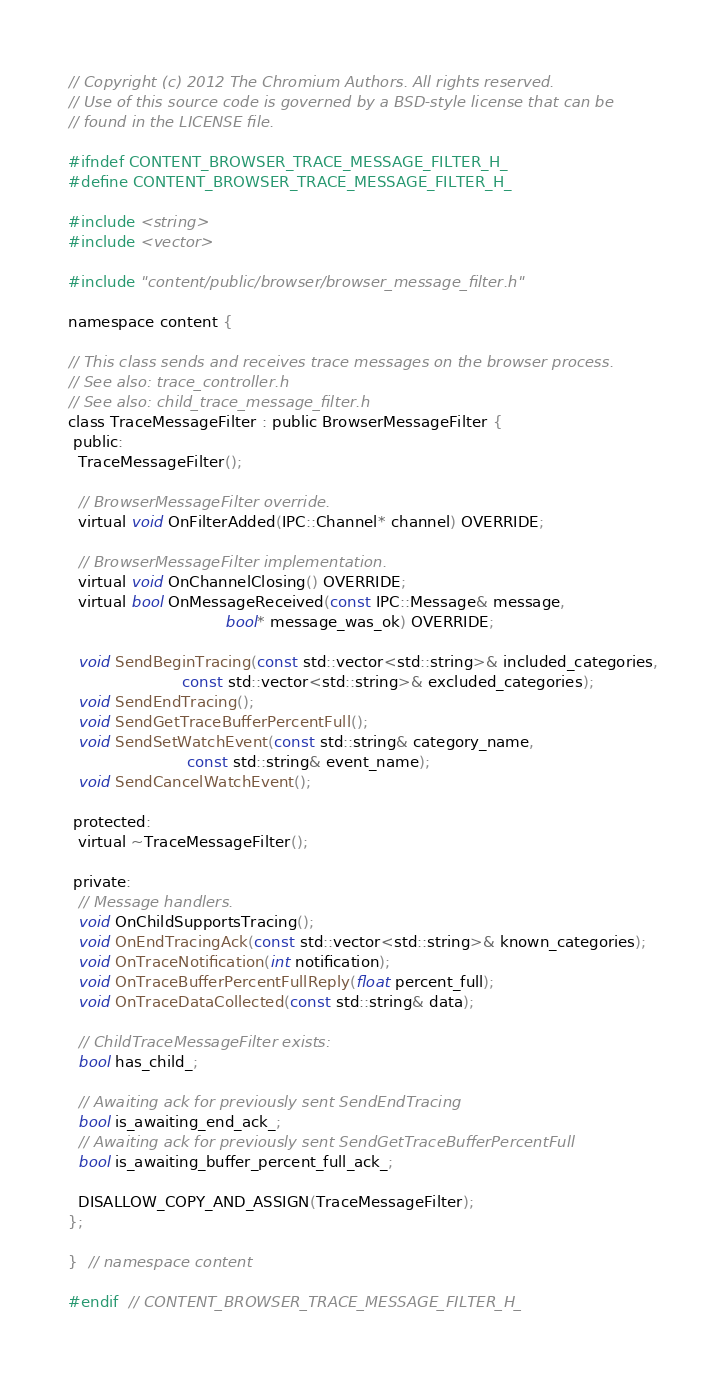Convert code to text. <code><loc_0><loc_0><loc_500><loc_500><_C_>// Copyright (c) 2012 The Chromium Authors. All rights reserved.
// Use of this source code is governed by a BSD-style license that can be
// found in the LICENSE file.

#ifndef CONTENT_BROWSER_TRACE_MESSAGE_FILTER_H_
#define CONTENT_BROWSER_TRACE_MESSAGE_FILTER_H_

#include <string>
#include <vector>

#include "content/public/browser/browser_message_filter.h"

namespace content {

// This class sends and receives trace messages on the browser process.
// See also: trace_controller.h
// See also: child_trace_message_filter.h
class TraceMessageFilter : public BrowserMessageFilter {
 public:
  TraceMessageFilter();

  // BrowserMessageFilter override.
  virtual void OnFilterAdded(IPC::Channel* channel) OVERRIDE;

  // BrowserMessageFilter implementation.
  virtual void OnChannelClosing() OVERRIDE;
  virtual bool OnMessageReceived(const IPC::Message& message,
                                 bool* message_was_ok) OVERRIDE;

  void SendBeginTracing(const std::vector<std::string>& included_categories,
                        const std::vector<std::string>& excluded_categories);
  void SendEndTracing();
  void SendGetTraceBufferPercentFull();
  void SendSetWatchEvent(const std::string& category_name,
                         const std::string& event_name);
  void SendCancelWatchEvent();

 protected:
  virtual ~TraceMessageFilter();

 private:
  // Message handlers.
  void OnChildSupportsTracing();
  void OnEndTracingAck(const std::vector<std::string>& known_categories);
  void OnTraceNotification(int notification);
  void OnTraceBufferPercentFullReply(float percent_full);
  void OnTraceDataCollected(const std::string& data);

  // ChildTraceMessageFilter exists:
  bool has_child_;

  // Awaiting ack for previously sent SendEndTracing
  bool is_awaiting_end_ack_;
  // Awaiting ack for previously sent SendGetTraceBufferPercentFull
  bool is_awaiting_buffer_percent_full_ack_;

  DISALLOW_COPY_AND_ASSIGN(TraceMessageFilter);
};

}  // namespace content

#endif  // CONTENT_BROWSER_TRACE_MESSAGE_FILTER_H_
</code> 